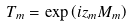<formula> <loc_0><loc_0><loc_500><loc_500>T _ { m } = \exp \left ( i z _ { m } M _ { m } \right )</formula> 